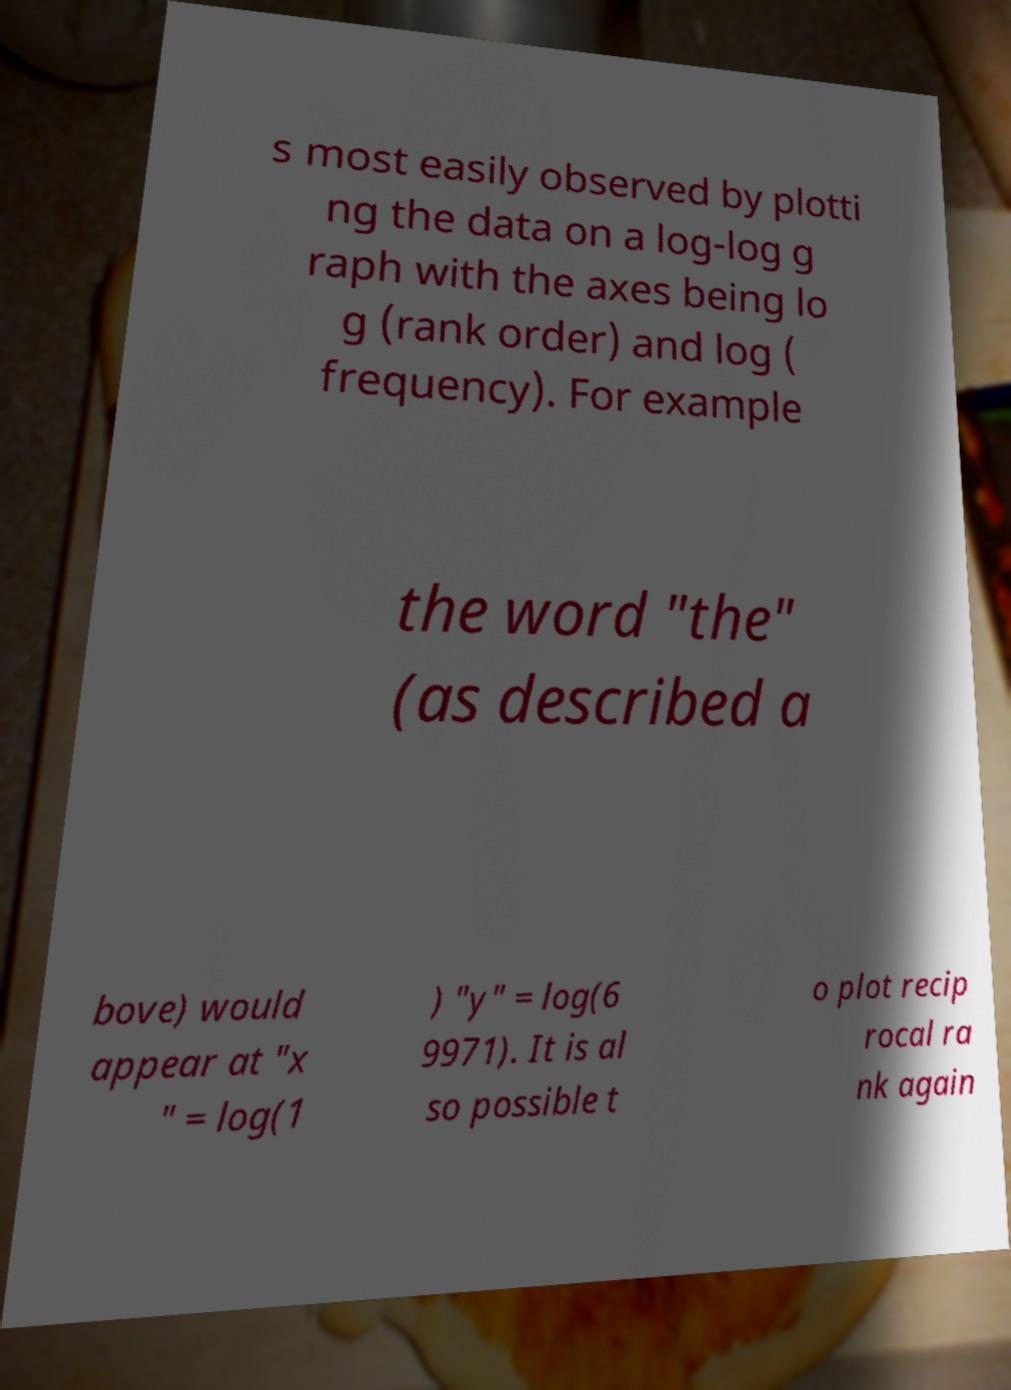Can you accurately transcribe the text from the provided image for me? s most easily observed by plotti ng the data on a log-log g raph with the axes being lo g (rank order) and log ( frequency). For example the word "the" (as described a bove) would appear at "x " = log(1 ) "y" = log(6 9971). It is al so possible t o plot recip rocal ra nk again 